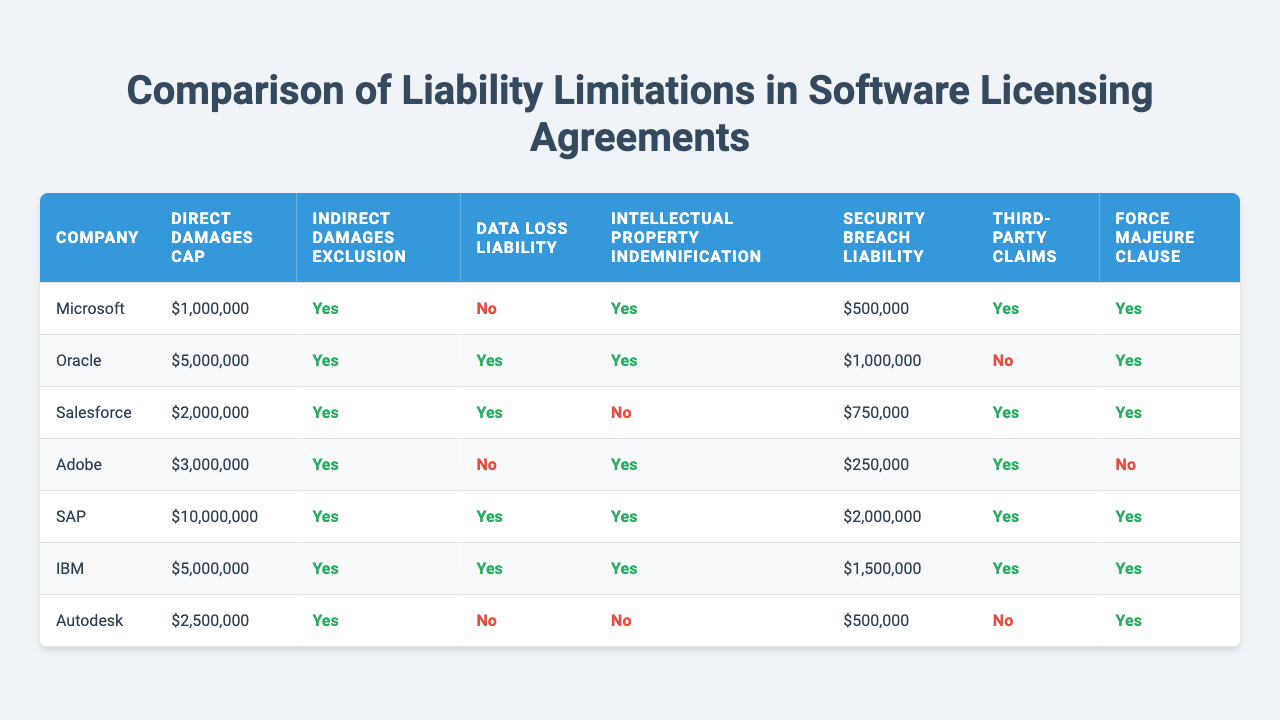What is the direct damages cap for Salesforce? The direct damages cap for Salesforce is shown in the first column of the table under the 'Salesforce' row, which indicates it is 2,000,000.
Answer: 2,000,000 Which companies exclude indirect damages? The companies that exclude indirect damages can be identified from the respective 'Indirect damages exclusion' columns. The companies are Oracle, Salesforce, SAP, and IBM, as they have 'Yes' next to their names.
Answer: Oracle, Salesforce, SAP, IBM What is the total liability cap for Microsoft and Adobe combined? The total liability cap is the sum of the direct damages cap for both Microsoft (1,000,000) and Adobe (3,000,000). Thus, 1,000,000 + 3,000,000 = 4,000,000.
Answer: 4,000,000 Does Autodesk have a security breach liability? In the 'Security breach liability' column, Autodesk has a 'No' indicated, so they do not have a security breach liability.
Answer: No How many companies provide indemnification for intellectual property? To determine this, inspect the column for 'Intellectual property indemnification'. The companies that indicate 'Yes' in this column are Microsoft, Oracle, Adobe, and IBM, making a total of four.
Answer: 4 What is the average value of the direct damages cap across all listed companies? First, sum the direct damages cap values: (1,000,000 + 5,000,000 + 2,000,000 + 3,000,000 + 10,000,000 + 5,000,000 + 2,500,000) = 29,500,000. There are 7 companies, so the average is 29,500,000 / 7 = approximately 4,214,286.
Answer: 4,214,286 Which company has the lowest data loss liability? To find the lowest data loss liability, look in the 'Data loss liability' column. The value for Autodesk is 'No', indicating they do not have a data loss liability, which can be considered the lowest.
Answer: Autodesk Is there a force majeure clause in the agreements of Microsoft and SAP? Check the 'Force majeure clause' column for both companies: Microsoft has 'Yes', and SAP has 'Yes' as well, indicating that both companies include a force majeure clause in their agreements.
Answer: Yes, both Which company has the highest caps on direct damages and security breach liability combined? To find this, we sum the direct damages cap and the security breach liability for each company. The highest combination is found at SAP: 10,000,000 (direct damages) + 2,000,000 (security breach) = 12,000,000.
Answer: SAP What percentage of companies exclude third-party claims? Check the 'Third-party claims' column for the number of companies that have 'No.' From the table, only Salesforce and Autodesk exclude third-party claims which gives us 2 out of 7 companies. The percentage is (2/7) * 100 = approximately 28.57%.
Answer: 28.57% 